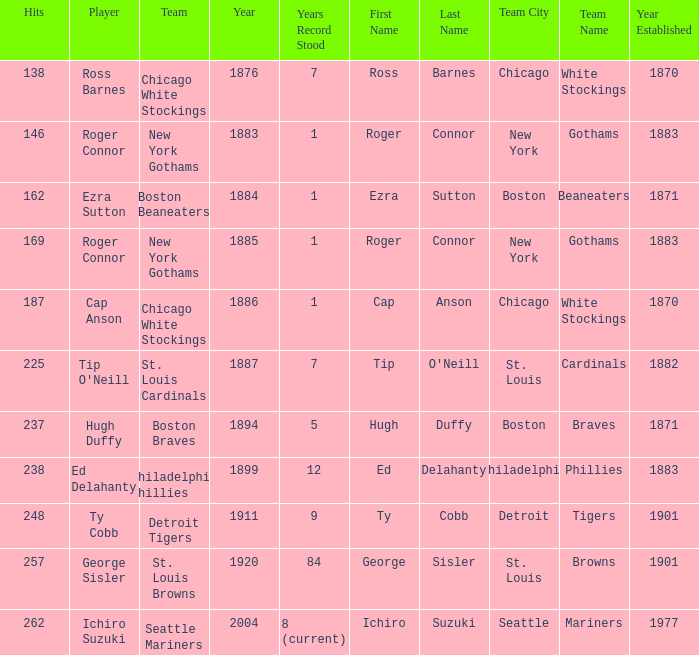Identify the fewest hits for a year before 1920 and the player ed delahanty. 238.0. 